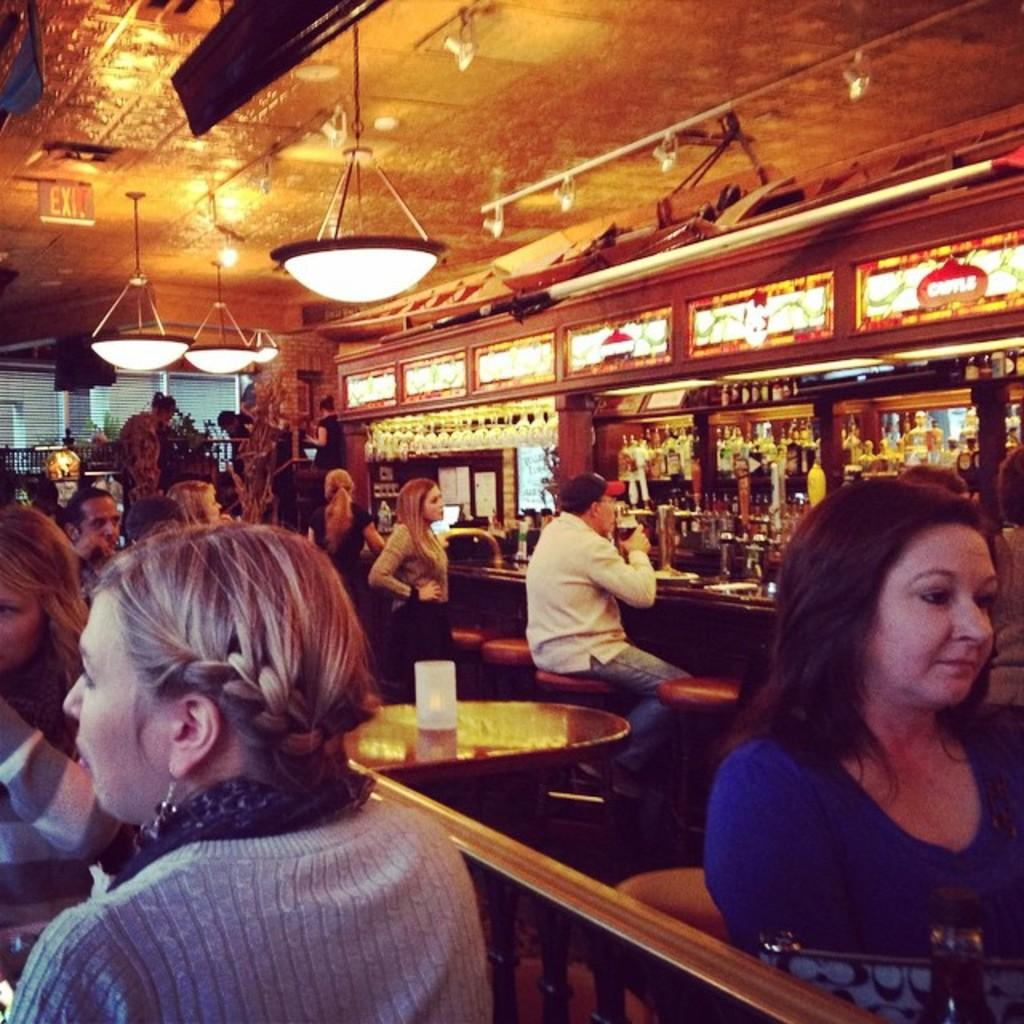What type of objects can be seen in the image that emit light? There are lights in the image. What type of objects can be seen in the image that display information or images? There are screens in the image. What type of objects can be seen in the image that are used for advertising or conveying information? There are banners in the image. What type of objects can be seen in the image that people sit on? There are chairs in the image. What type of objects can be seen in the image that people use for placing items or eating? There are tables in the image. What type of object can be seen on a table in the image? There is a glass on a table in the image. What type of owl can be seen sitting on a chair in the image? There is no owl present in the image; it features lights, screens, banners, chairs, tables, and a glass. What is the desire of the people sitting on chairs in the image? The image does not provide information about the desires of the people sitting on chairs; it only shows their presence and the objects around them. 